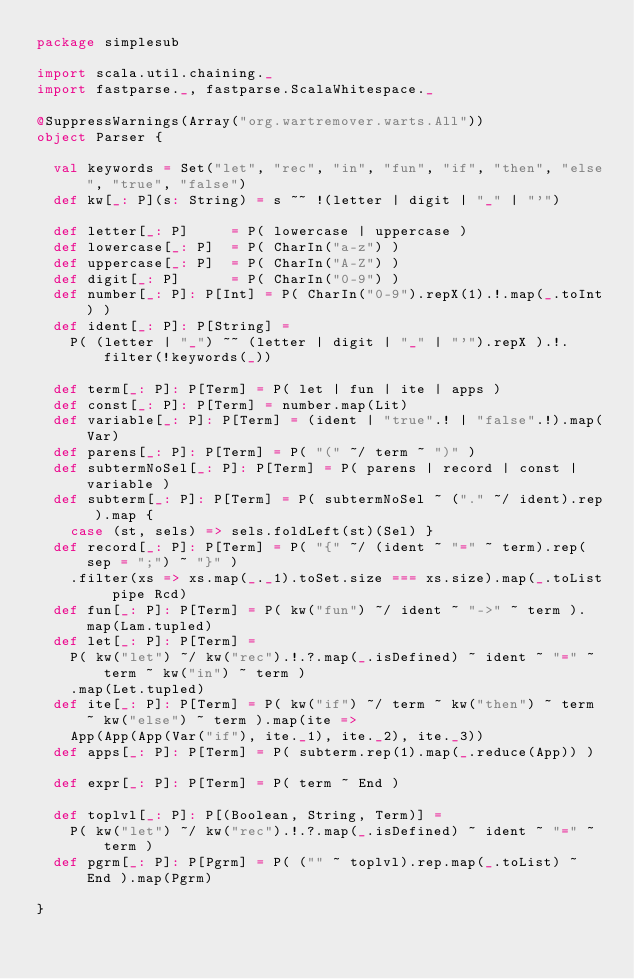<code> <loc_0><loc_0><loc_500><loc_500><_Scala_>package simplesub

import scala.util.chaining._
import fastparse._, fastparse.ScalaWhitespace._

@SuppressWarnings(Array("org.wartremover.warts.All"))
object Parser {
  
  val keywords = Set("let", "rec", "in", "fun", "if", "then", "else", "true", "false")
  def kw[_: P](s: String) = s ~~ !(letter | digit | "_" | "'")
  
  def letter[_: P]     = P( lowercase | uppercase )
  def lowercase[_: P]  = P( CharIn("a-z") )
  def uppercase[_: P]  = P( CharIn("A-Z") )
  def digit[_: P]      = P( CharIn("0-9") )
  def number[_: P]: P[Int] = P( CharIn("0-9").repX(1).!.map(_.toInt) )
  def ident[_: P]: P[String] =
    P( (letter | "_") ~~ (letter | digit | "_" | "'").repX ).!.filter(!keywords(_))
  
  def term[_: P]: P[Term] = P( let | fun | ite | apps )
  def const[_: P]: P[Term] = number.map(Lit)
  def variable[_: P]: P[Term] = (ident | "true".! | "false".!).map(Var)
  def parens[_: P]: P[Term] = P( "(" ~/ term ~ ")" )
  def subtermNoSel[_: P]: P[Term] = P( parens | record | const | variable )
  def subterm[_: P]: P[Term] = P( subtermNoSel ~ ("." ~/ ident).rep ).map {
    case (st, sels) => sels.foldLeft(st)(Sel) }
  def record[_: P]: P[Term] = P( "{" ~/ (ident ~ "=" ~ term).rep(sep = ";") ~ "}" )
    .filter(xs => xs.map(_._1).toSet.size === xs.size).map(_.toList pipe Rcd)
  def fun[_: P]: P[Term] = P( kw("fun") ~/ ident ~ "->" ~ term ).map(Lam.tupled)
  def let[_: P]: P[Term] =
    P( kw("let") ~/ kw("rec").!.?.map(_.isDefined) ~ ident ~ "=" ~ term ~ kw("in") ~ term )
    .map(Let.tupled)
  def ite[_: P]: P[Term] = P( kw("if") ~/ term ~ kw("then") ~ term ~ kw("else") ~ term ).map(ite =>
    App(App(App(Var("if"), ite._1), ite._2), ite._3))
  def apps[_: P]: P[Term] = P( subterm.rep(1).map(_.reduce(App)) )
  
  def expr[_: P]: P[Term] = P( term ~ End )
  
  def toplvl[_: P]: P[(Boolean, String, Term)] =
    P( kw("let") ~/ kw("rec").!.?.map(_.isDefined) ~ ident ~ "=" ~ term )
  def pgrm[_: P]: P[Pgrm] = P( ("" ~ toplvl).rep.map(_.toList) ~ End ).map(Pgrm)
  
}
</code> 